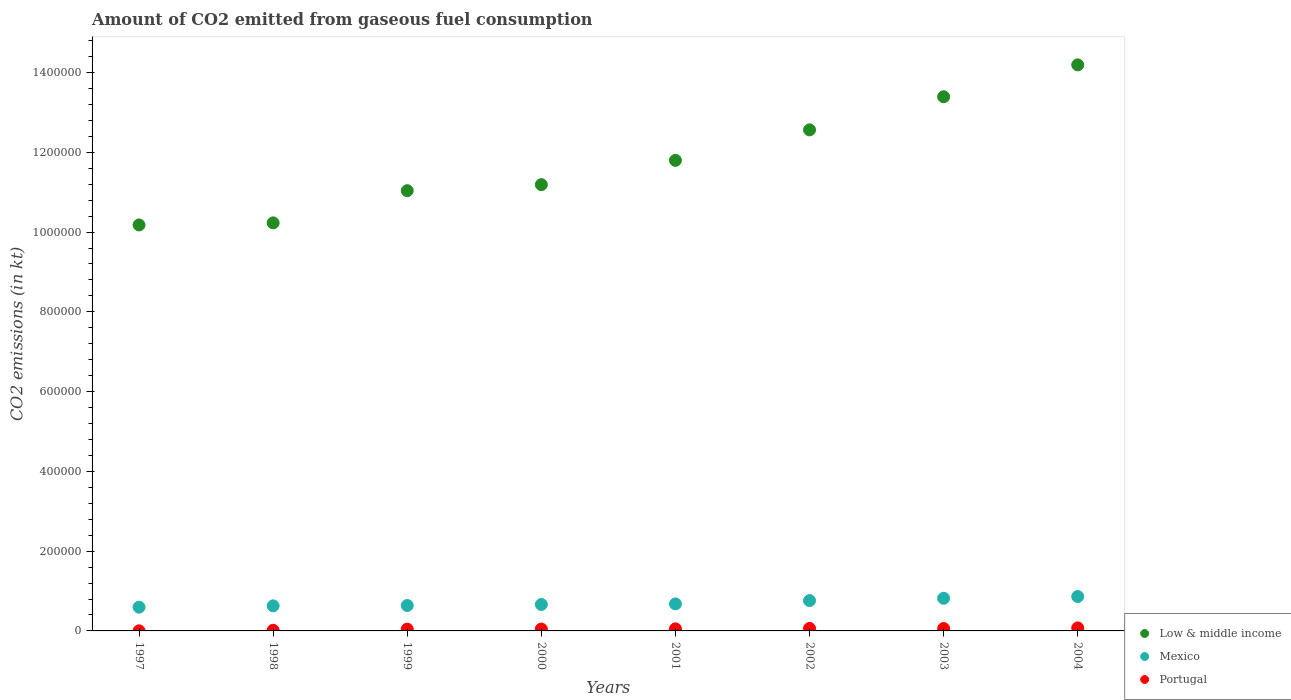How many different coloured dotlines are there?
Your answer should be compact. 3. What is the amount of CO2 emitted in Low & middle income in 2002?
Provide a succinct answer. 1.26e+06. Across all years, what is the maximum amount of CO2 emitted in Portugal?
Offer a terse response. 7565.02. Across all years, what is the minimum amount of CO2 emitted in Portugal?
Provide a short and direct response. 198.02. In which year was the amount of CO2 emitted in Low & middle income minimum?
Your answer should be compact. 1997. What is the total amount of CO2 emitted in Low & middle income in the graph?
Provide a short and direct response. 9.46e+06. What is the difference between the amount of CO2 emitted in Low & middle income in 2001 and that in 2004?
Your response must be concise. -2.39e+05. What is the difference between the amount of CO2 emitted in Low & middle income in 1998 and the amount of CO2 emitted in Portugal in 2003?
Give a very brief answer. 1.02e+06. What is the average amount of CO2 emitted in Portugal per year?
Provide a short and direct response. 4490.7. In the year 2003, what is the difference between the amount of CO2 emitted in Portugal and amount of CO2 emitted in Low & middle income?
Keep it short and to the point. -1.33e+06. In how many years, is the amount of CO2 emitted in Low & middle income greater than 1240000 kt?
Provide a short and direct response. 3. What is the ratio of the amount of CO2 emitted in Portugal in 1997 to that in 2000?
Provide a succinct answer. 0.04. Is the amount of CO2 emitted in Mexico in 2003 less than that in 2004?
Keep it short and to the point. Yes. What is the difference between the highest and the second highest amount of CO2 emitted in Low & middle income?
Ensure brevity in your answer.  7.99e+04. What is the difference between the highest and the lowest amount of CO2 emitted in Portugal?
Your answer should be compact. 7367. In how many years, is the amount of CO2 emitted in Low & middle income greater than the average amount of CO2 emitted in Low & middle income taken over all years?
Offer a very short reply. 3. Does the amount of CO2 emitted in Mexico monotonically increase over the years?
Give a very brief answer. Yes. How many dotlines are there?
Offer a terse response. 3. What is the difference between two consecutive major ticks on the Y-axis?
Make the answer very short. 2.00e+05. Are the values on the major ticks of Y-axis written in scientific E-notation?
Your response must be concise. No. Does the graph contain grids?
Provide a short and direct response. No. Where does the legend appear in the graph?
Make the answer very short. Bottom right. What is the title of the graph?
Your answer should be very brief. Amount of CO2 emitted from gaseous fuel consumption. Does "New Caledonia" appear as one of the legend labels in the graph?
Offer a terse response. No. What is the label or title of the Y-axis?
Keep it short and to the point. CO2 emissions (in kt). What is the CO2 emissions (in kt) of Low & middle income in 1997?
Provide a short and direct response. 1.02e+06. What is the CO2 emissions (in kt) in Mexico in 1997?
Keep it short and to the point. 5.96e+04. What is the CO2 emissions (in kt) in Portugal in 1997?
Your answer should be very brief. 198.02. What is the CO2 emissions (in kt) of Low & middle income in 1998?
Offer a very short reply. 1.02e+06. What is the CO2 emissions (in kt) of Mexico in 1998?
Offer a very short reply. 6.29e+04. What is the CO2 emissions (in kt) in Portugal in 1998?
Provide a short and direct response. 1595.14. What is the CO2 emissions (in kt) of Low & middle income in 1999?
Your answer should be compact. 1.10e+06. What is the CO2 emissions (in kt) in Mexico in 1999?
Give a very brief answer. 6.37e+04. What is the CO2 emissions (in kt) in Portugal in 1999?
Your response must be concise. 4455.4. What is the CO2 emissions (in kt) in Low & middle income in 2000?
Offer a terse response. 1.12e+06. What is the CO2 emissions (in kt) of Mexico in 2000?
Your answer should be very brief. 6.63e+04. What is the CO2 emissions (in kt) of Portugal in 2000?
Your answer should be very brief. 4657.09. What is the CO2 emissions (in kt) of Low & middle income in 2001?
Provide a short and direct response. 1.18e+06. What is the CO2 emissions (in kt) in Mexico in 2001?
Make the answer very short. 6.78e+04. What is the CO2 emissions (in kt) of Portugal in 2001?
Ensure brevity in your answer.  5163.14. What is the CO2 emissions (in kt) of Low & middle income in 2002?
Your response must be concise. 1.26e+06. What is the CO2 emissions (in kt) in Mexico in 2002?
Provide a succinct answer. 7.60e+04. What is the CO2 emissions (in kt) in Portugal in 2002?
Your answer should be very brief. 6252.23. What is the CO2 emissions (in kt) in Low & middle income in 2003?
Ensure brevity in your answer.  1.34e+06. What is the CO2 emissions (in kt) in Mexico in 2003?
Keep it short and to the point. 8.18e+04. What is the CO2 emissions (in kt) in Portugal in 2003?
Your response must be concise. 6039.55. What is the CO2 emissions (in kt) of Low & middle income in 2004?
Keep it short and to the point. 1.42e+06. What is the CO2 emissions (in kt) of Mexico in 2004?
Offer a terse response. 8.62e+04. What is the CO2 emissions (in kt) of Portugal in 2004?
Offer a terse response. 7565.02. Across all years, what is the maximum CO2 emissions (in kt) of Low & middle income?
Your response must be concise. 1.42e+06. Across all years, what is the maximum CO2 emissions (in kt) of Mexico?
Give a very brief answer. 8.62e+04. Across all years, what is the maximum CO2 emissions (in kt) of Portugal?
Keep it short and to the point. 7565.02. Across all years, what is the minimum CO2 emissions (in kt) of Low & middle income?
Your answer should be very brief. 1.02e+06. Across all years, what is the minimum CO2 emissions (in kt) of Mexico?
Your answer should be compact. 5.96e+04. Across all years, what is the minimum CO2 emissions (in kt) in Portugal?
Your answer should be very brief. 198.02. What is the total CO2 emissions (in kt) of Low & middle income in the graph?
Ensure brevity in your answer.  9.46e+06. What is the total CO2 emissions (in kt) of Mexico in the graph?
Provide a succinct answer. 5.64e+05. What is the total CO2 emissions (in kt) in Portugal in the graph?
Your answer should be compact. 3.59e+04. What is the difference between the CO2 emissions (in kt) in Low & middle income in 1997 and that in 1998?
Your answer should be compact. -5197.05. What is the difference between the CO2 emissions (in kt) of Mexico in 1997 and that in 1998?
Keep it short and to the point. -3300.3. What is the difference between the CO2 emissions (in kt) of Portugal in 1997 and that in 1998?
Give a very brief answer. -1397.13. What is the difference between the CO2 emissions (in kt) of Low & middle income in 1997 and that in 1999?
Give a very brief answer. -8.59e+04. What is the difference between the CO2 emissions (in kt) in Mexico in 1997 and that in 1999?
Make the answer very short. -4154.71. What is the difference between the CO2 emissions (in kt) in Portugal in 1997 and that in 1999?
Keep it short and to the point. -4257.39. What is the difference between the CO2 emissions (in kt) in Low & middle income in 1997 and that in 2000?
Make the answer very short. -1.01e+05. What is the difference between the CO2 emissions (in kt) of Mexico in 1997 and that in 2000?
Offer a terse response. -6703.28. What is the difference between the CO2 emissions (in kt) in Portugal in 1997 and that in 2000?
Your response must be concise. -4459.07. What is the difference between the CO2 emissions (in kt) of Low & middle income in 1997 and that in 2001?
Make the answer very short. -1.62e+05. What is the difference between the CO2 emissions (in kt) in Mexico in 1997 and that in 2001?
Offer a very short reply. -8228.75. What is the difference between the CO2 emissions (in kt) in Portugal in 1997 and that in 2001?
Provide a succinct answer. -4965.12. What is the difference between the CO2 emissions (in kt) in Low & middle income in 1997 and that in 2002?
Make the answer very short. -2.38e+05. What is the difference between the CO2 emissions (in kt) in Mexico in 1997 and that in 2002?
Offer a terse response. -1.65e+04. What is the difference between the CO2 emissions (in kt) of Portugal in 1997 and that in 2002?
Offer a very short reply. -6054.22. What is the difference between the CO2 emissions (in kt) in Low & middle income in 1997 and that in 2003?
Offer a terse response. -3.21e+05. What is the difference between the CO2 emissions (in kt) of Mexico in 1997 and that in 2003?
Keep it short and to the point. -2.23e+04. What is the difference between the CO2 emissions (in kt) in Portugal in 1997 and that in 2003?
Make the answer very short. -5841.53. What is the difference between the CO2 emissions (in kt) of Low & middle income in 1997 and that in 2004?
Offer a very short reply. -4.01e+05. What is the difference between the CO2 emissions (in kt) of Mexico in 1997 and that in 2004?
Your answer should be very brief. -2.67e+04. What is the difference between the CO2 emissions (in kt) of Portugal in 1997 and that in 2004?
Provide a succinct answer. -7367. What is the difference between the CO2 emissions (in kt) of Low & middle income in 1998 and that in 1999?
Your response must be concise. -8.07e+04. What is the difference between the CO2 emissions (in kt) of Mexico in 1998 and that in 1999?
Your answer should be compact. -854.41. What is the difference between the CO2 emissions (in kt) of Portugal in 1998 and that in 1999?
Provide a short and direct response. -2860.26. What is the difference between the CO2 emissions (in kt) in Low & middle income in 1998 and that in 2000?
Provide a short and direct response. -9.59e+04. What is the difference between the CO2 emissions (in kt) of Mexico in 1998 and that in 2000?
Your answer should be compact. -3402.98. What is the difference between the CO2 emissions (in kt) of Portugal in 1998 and that in 2000?
Give a very brief answer. -3061.95. What is the difference between the CO2 emissions (in kt) in Low & middle income in 1998 and that in 2001?
Keep it short and to the point. -1.57e+05. What is the difference between the CO2 emissions (in kt) in Mexico in 1998 and that in 2001?
Your answer should be compact. -4928.45. What is the difference between the CO2 emissions (in kt) of Portugal in 1998 and that in 2001?
Your response must be concise. -3567.99. What is the difference between the CO2 emissions (in kt) in Low & middle income in 1998 and that in 2002?
Your answer should be very brief. -2.33e+05. What is the difference between the CO2 emissions (in kt) in Mexico in 1998 and that in 2002?
Your response must be concise. -1.32e+04. What is the difference between the CO2 emissions (in kt) in Portugal in 1998 and that in 2002?
Make the answer very short. -4657.09. What is the difference between the CO2 emissions (in kt) in Low & middle income in 1998 and that in 2003?
Provide a succinct answer. -3.16e+05. What is the difference between the CO2 emissions (in kt) in Mexico in 1998 and that in 2003?
Make the answer very short. -1.90e+04. What is the difference between the CO2 emissions (in kt) in Portugal in 1998 and that in 2003?
Your answer should be compact. -4444.4. What is the difference between the CO2 emissions (in kt) in Low & middle income in 1998 and that in 2004?
Offer a very short reply. -3.96e+05. What is the difference between the CO2 emissions (in kt) of Mexico in 1998 and that in 2004?
Your response must be concise. -2.34e+04. What is the difference between the CO2 emissions (in kt) of Portugal in 1998 and that in 2004?
Offer a terse response. -5969.88. What is the difference between the CO2 emissions (in kt) in Low & middle income in 1999 and that in 2000?
Offer a very short reply. -1.52e+04. What is the difference between the CO2 emissions (in kt) in Mexico in 1999 and that in 2000?
Offer a very short reply. -2548.57. What is the difference between the CO2 emissions (in kt) in Portugal in 1999 and that in 2000?
Make the answer very short. -201.69. What is the difference between the CO2 emissions (in kt) of Low & middle income in 1999 and that in 2001?
Provide a short and direct response. -7.61e+04. What is the difference between the CO2 emissions (in kt) in Mexico in 1999 and that in 2001?
Offer a very short reply. -4074.04. What is the difference between the CO2 emissions (in kt) of Portugal in 1999 and that in 2001?
Offer a very short reply. -707.73. What is the difference between the CO2 emissions (in kt) in Low & middle income in 1999 and that in 2002?
Keep it short and to the point. -1.53e+05. What is the difference between the CO2 emissions (in kt) in Mexico in 1999 and that in 2002?
Your answer should be very brief. -1.23e+04. What is the difference between the CO2 emissions (in kt) in Portugal in 1999 and that in 2002?
Provide a succinct answer. -1796.83. What is the difference between the CO2 emissions (in kt) of Low & middle income in 1999 and that in 2003?
Provide a short and direct response. -2.36e+05. What is the difference between the CO2 emissions (in kt) in Mexico in 1999 and that in 2003?
Your answer should be compact. -1.81e+04. What is the difference between the CO2 emissions (in kt) of Portugal in 1999 and that in 2003?
Your answer should be compact. -1584.14. What is the difference between the CO2 emissions (in kt) in Low & middle income in 1999 and that in 2004?
Provide a succinct answer. -3.15e+05. What is the difference between the CO2 emissions (in kt) in Mexico in 1999 and that in 2004?
Offer a terse response. -2.25e+04. What is the difference between the CO2 emissions (in kt) in Portugal in 1999 and that in 2004?
Provide a succinct answer. -3109.62. What is the difference between the CO2 emissions (in kt) in Low & middle income in 2000 and that in 2001?
Your answer should be very brief. -6.09e+04. What is the difference between the CO2 emissions (in kt) in Mexico in 2000 and that in 2001?
Offer a terse response. -1525.47. What is the difference between the CO2 emissions (in kt) in Portugal in 2000 and that in 2001?
Keep it short and to the point. -506.05. What is the difference between the CO2 emissions (in kt) in Low & middle income in 2000 and that in 2002?
Your response must be concise. -1.37e+05. What is the difference between the CO2 emissions (in kt) in Mexico in 2000 and that in 2002?
Ensure brevity in your answer.  -9750.55. What is the difference between the CO2 emissions (in kt) of Portugal in 2000 and that in 2002?
Give a very brief answer. -1595.14. What is the difference between the CO2 emissions (in kt) in Low & middle income in 2000 and that in 2003?
Ensure brevity in your answer.  -2.20e+05. What is the difference between the CO2 emissions (in kt) in Mexico in 2000 and that in 2003?
Make the answer very short. -1.56e+04. What is the difference between the CO2 emissions (in kt) in Portugal in 2000 and that in 2003?
Give a very brief answer. -1382.46. What is the difference between the CO2 emissions (in kt) of Low & middle income in 2000 and that in 2004?
Give a very brief answer. -3.00e+05. What is the difference between the CO2 emissions (in kt) of Mexico in 2000 and that in 2004?
Offer a terse response. -2.00e+04. What is the difference between the CO2 emissions (in kt) in Portugal in 2000 and that in 2004?
Your answer should be compact. -2907.93. What is the difference between the CO2 emissions (in kt) of Low & middle income in 2001 and that in 2002?
Your response must be concise. -7.65e+04. What is the difference between the CO2 emissions (in kt) in Mexico in 2001 and that in 2002?
Provide a short and direct response. -8225.08. What is the difference between the CO2 emissions (in kt) of Portugal in 2001 and that in 2002?
Your answer should be compact. -1089.1. What is the difference between the CO2 emissions (in kt) of Low & middle income in 2001 and that in 2003?
Provide a succinct answer. -1.59e+05. What is the difference between the CO2 emissions (in kt) in Mexico in 2001 and that in 2003?
Keep it short and to the point. -1.41e+04. What is the difference between the CO2 emissions (in kt) of Portugal in 2001 and that in 2003?
Provide a short and direct response. -876.41. What is the difference between the CO2 emissions (in kt) of Low & middle income in 2001 and that in 2004?
Your response must be concise. -2.39e+05. What is the difference between the CO2 emissions (in kt) of Mexico in 2001 and that in 2004?
Your answer should be compact. -1.84e+04. What is the difference between the CO2 emissions (in kt) in Portugal in 2001 and that in 2004?
Keep it short and to the point. -2401.89. What is the difference between the CO2 emissions (in kt) in Low & middle income in 2002 and that in 2003?
Your answer should be compact. -8.30e+04. What is the difference between the CO2 emissions (in kt) in Mexico in 2002 and that in 2003?
Offer a very short reply. -5837.86. What is the difference between the CO2 emissions (in kt) in Portugal in 2002 and that in 2003?
Offer a terse response. 212.69. What is the difference between the CO2 emissions (in kt) in Low & middle income in 2002 and that in 2004?
Provide a short and direct response. -1.63e+05. What is the difference between the CO2 emissions (in kt) of Mexico in 2002 and that in 2004?
Your answer should be very brief. -1.02e+04. What is the difference between the CO2 emissions (in kt) in Portugal in 2002 and that in 2004?
Offer a very short reply. -1312.79. What is the difference between the CO2 emissions (in kt) of Low & middle income in 2003 and that in 2004?
Keep it short and to the point. -7.99e+04. What is the difference between the CO2 emissions (in kt) in Mexico in 2003 and that in 2004?
Provide a succinct answer. -4374.73. What is the difference between the CO2 emissions (in kt) of Portugal in 2003 and that in 2004?
Keep it short and to the point. -1525.47. What is the difference between the CO2 emissions (in kt) in Low & middle income in 1997 and the CO2 emissions (in kt) in Mexico in 1998?
Your answer should be compact. 9.55e+05. What is the difference between the CO2 emissions (in kt) of Low & middle income in 1997 and the CO2 emissions (in kt) of Portugal in 1998?
Offer a terse response. 1.02e+06. What is the difference between the CO2 emissions (in kt) of Mexico in 1997 and the CO2 emissions (in kt) of Portugal in 1998?
Offer a very short reply. 5.80e+04. What is the difference between the CO2 emissions (in kt) of Low & middle income in 1997 and the CO2 emissions (in kt) of Mexico in 1999?
Make the answer very short. 9.54e+05. What is the difference between the CO2 emissions (in kt) in Low & middle income in 1997 and the CO2 emissions (in kt) in Portugal in 1999?
Keep it short and to the point. 1.01e+06. What is the difference between the CO2 emissions (in kt) of Mexico in 1997 and the CO2 emissions (in kt) of Portugal in 1999?
Your answer should be compact. 5.51e+04. What is the difference between the CO2 emissions (in kt) of Low & middle income in 1997 and the CO2 emissions (in kt) of Mexico in 2000?
Ensure brevity in your answer.  9.52e+05. What is the difference between the CO2 emissions (in kt) of Low & middle income in 1997 and the CO2 emissions (in kt) of Portugal in 2000?
Provide a succinct answer. 1.01e+06. What is the difference between the CO2 emissions (in kt) in Mexico in 1997 and the CO2 emissions (in kt) in Portugal in 2000?
Ensure brevity in your answer.  5.49e+04. What is the difference between the CO2 emissions (in kt) in Low & middle income in 1997 and the CO2 emissions (in kt) in Mexico in 2001?
Keep it short and to the point. 9.50e+05. What is the difference between the CO2 emissions (in kt) in Low & middle income in 1997 and the CO2 emissions (in kt) in Portugal in 2001?
Offer a terse response. 1.01e+06. What is the difference between the CO2 emissions (in kt) of Mexico in 1997 and the CO2 emissions (in kt) of Portugal in 2001?
Offer a terse response. 5.44e+04. What is the difference between the CO2 emissions (in kt) of Low & middle income in 1997 and the CO2 emissions (in kt) of Mexico in 2002?
Give a very brief answer. 9.42e+05. What is the difference between the CO2 emissions (in kt) in Low & middle income in 1997 and the CO2 emissions (in kt) in Portugal in 2002?
Offer a terse response. 1.01e+06. What is the difference between the CO2 emissions (in kt) in Mexico in 1997 and the CO2 emissions (in kt) in Portugal in 2002?
Ensure brevity in your answer.  5.33e+04. What is the difference between the CO2 emissions (in kt) in Low & middle income in 1997 and the CO2 emissions (in kt) in Mexico in 2003?
Keep it short and to the point. 9.36e+05. What is the difference between the CO2 emissions (in kt) in Low & middle income in 1997 and the CO2 emissions (in kt) in Portugal in 2003?
Offer a terse response. 1.01e+06. What is the difference between the CO2 emissions (in kt) of Mexico in 1997 and the CO2 emissions (in kt) of Portugal in 2003?
Your response must be concise. 5.35e+04. What is the difference between the CO2 emissions (in kt) of Low & middle income in 1997 and the CO2 emissions (in kt) of Mexico in 2004?
Offer a terse response. 9.32e+05. What is the difference between the CO2 emissions (in kt) in Low & middle income in 1997 and the CO2 emissions (in kt) in Portugal in 2004?
Make the answer very short. 1.01e+06. What is the difference between the CO2 emissions (in kt) of Mexico in 1997 and the CO2 emissions (in kt) of Portugal in 2004?
Make the answer very short. 5.20e+04. What is the difference between the CO2 emissions (in kt) in Low & middle income in 1998 and the CO2 emissions (in kt) in Mexico in 1999?
Your answer should be compact. 9.59e+05. What is the difference between the CO2 emissions (in kt) in Low & middle income in 1998 and the CO2 emissions (in kt) in Portugal in 1999?
Offer a terse response. 1.02e+06. What is the difference between the CO2 emissions (in kt) of Mexico in 1998 and the CO2 emissions (in kt) of Portugal in 1999?
Your answer should be compact. 5.84e+04. What is the difference between the CO2 emissions (in kt) in Low & middle income in 1998 and the CO2 emissions (in kt) in Mexico in 2000?
Provide a short and direct response. 9.57e+05. What is the difference between the CO2 emissions (in kt) of Low & middle income in 1998 and the CO2 emissions (in kt) of Portugal in 2000?
Your answer should be compact. 1.02e+06. What is the difference between the CO2 emissions (in kt) in Mexico in 1998 and the CO2 emissions (in kt) in Portugal in 2000?
Give a very brief answer. 5.82e+04. What is the difference between the CO2 emissions (in kt) in Low & middle income in 1998 and the CO2 emissions (in kt) in Mexico in 2001?
Make the answer very short. 9.55e+05. What is the difference between the CO2 emissions (in kt) of Low & middle income in 1998 and the CO2 emissions (in kt) of Portugal in 2001?
Offer a very short reply. 1.02e+06. What is the difference between the CO2 emissions (in kt) of Mexico in 1998 and the CO2 emissions (in kt) of Portugal in 2001?
Ensure brevity in your answer.  5.77e+04. What is the difference between the CO2 emissions (in kt) of Low & middle income in 1998 and the CO2 emissions (in kt) of Mexico in 2002?
Your response must be concise. 9.47e+05. What is the difference between the CO2 emissions (in kt) of Low & middle income in 1998 and the CO2 emissions (in kt) of Portugal in 2002?
Provide a succinct answer. 1.02e+06. What is the difference between the CO2 emissions (in kt) in Mexico in 1998 and the CO2 emissions (in kt) in Portugal in 2002?
Provide a succinct answer. 5.66e+04. What is the difference between the CO2 emissions (in kt) of Low & middle income in 1998 and the CO2 emissions (in kt) of Mexico in 2003?
Offer a very short reply. 9.41e+05. What is the difference between the CO2 emissions (in kt) in Low & middle income in 1998 and the CO2 emissions (in kt) in Portugal in 2003?
Ensure brevity in your answer.  1.02e+06. What is the difference between the CO2 emissions (in kt) of Mexico in 1998 and the CO2 emissions (in kt) of Portugal in 2003?
Ensure brevity in your answer.  5.68e+04. What is the difference between the CO2 emissions (in kt) of Low & middle income in 1998 and the CO2 emissions (in kt) of Mexico in 2004?
Your answer should be compact. 9.37e+05. What is the difference between the CO2 emissions (in kt) of Low & middle income in 1998 and the CO2 emissions (in kt) of Portugal in 2004?
Offer a terse response. 1.02e+06. What is the difference between the CO2 emissions (in kt) in Mexico in 1998 and the CO2 emissions (in kt) in Portugal in 2004?
Ensure brevity in your answer.  5.53e+04. What is the difference between the CO2 emissions (in kt) in Low & middle income in 1999 and the CO2 emissions (in kt) in Mexico in 2000?
Your response must be concise. 1.04e+06. What is the difference between the CO2 emissions (in kt) of Low & middle income in 1999 and the CO2 emissions (in kt) of Portugal in 2000?
Give a very brief answer. 1.10e+06. What is the difference between the CO2 emissions (in kt) in Mexico in 1999 and the CO2 emissions (in kt) in Portugal in 2000?
Offer a terse response. 5.91e+04. What is the difference between the CO2 emissions (in kt) in Low & middle income in 1999 and the CO2 emissions (in kt) in Mexico in 2001?
Make the answer very short. 1.04e+06. What is the difference between the CO2 emissions (in kt) of Low & middle income in 1999 and the CO2 emissions (in kt) of Portugal in 2001?
Give a very brief answer. 1.10e+06. What is the difference between the CO2 emissions (in kt) of Mexico in 1999 and the CO2 emissions (in kt) of Portugal in 2001?
Your response must be concise. 5.85e+04. What is the difference between the CO2 emissions (in kt) in Low & middle income in 1999 and the CO2 emissions (in kt) in Mexico in 2002?
Ensure brevity in your answer.  1.03e+06. What is the difference between the CO2 emissions (in kt) in Low & middle income in 1999 and the CO2 emissions (in kt) in Portugal in 2002?
Your response must be concise. 1.10e+06. What is the difference between the CO2 emissions (in kt) of Mexico in 1999 and the CO2 emissions (in kt) of Portugal in 2002?
Offer a terse response. 5.75e+04. What is the difference between the CO2 emissions (in kt) of Low & middle income in 1999 and the CO2 emissions (in kt) of Mexico in 2003?
Provide a short and direct response. 1.02e+06. What is the difference between the CO2 emissions (in kt) of Low & middle income in 1999 and the CO2 emissions (in kt) of Portugal in 2003?
Ensure brevity in your answer.  1.10e+06. What is the difference between the CO2 emissions (in kt) of Mexico in 1999 and the CO2 emissions (in kt) of Portugal in 2003?
Offer a terse response. 5.77e+04. What is the difference between the CO2 emissions (in kt) of Low & middle income in 1999 and the CO2 emissions (in kt) of Mexico in 2004?
Offer a very short reply. 1.02e+06. What is the difference between the CO2 emissions (in kt) in Low & middle income in 1999 and the CO2 emissions (in kt) in Portugal in 2004?
Keep it short and to the point. 1.10e+06. What is the difference between the CO2 emissions (in kt) of Mexico in 1999 and the CO2 emissions (in kt) of Portugal in 2004?
Your answer should be compact. 5.61e+04. What is the difference between the CO2 emissions (in kt) of Low & middle income in 2000 and the CO2 emissions (in kt) of Mexico in 2001?
Provide a short and direct response. 1.05e+06. What is the difference between the CO2 emissions (in kt) of Low & middle income in 2000 and the CO2 emissions (in kt) of Portugal in 2001?
Provide a short and direct response. 1.11e+06. What is the difference between the CO2 emissions (in kt) in Mexico in 2000 and the CO2 emissions (in kt) in Portugal in 2001?
Offer a very short reply. 6.11e+04. What is the difference between the CO2 emissions (in kt) in Low & middle income in 2000 and the CO2 emissions (in kt) in Mexico in 2002?
Offer a very short reply. 1.04e+06. What is the difference between the CO2 emissions (in kt) of Low & middle income in 2000 and the CO2 emissions (in kt) of Portugal in 2002?
Offer a terse response. 1.11e+06. What is the difference between the CO2 emissions (in kt) in Mexico in 2000 and the CO2 emissions (in kt) in Portugal in 2002?
Ensure brevity in your answer.  6.00e+04. What is the difference between the CO2 emissions (in kt) in Low & middle income in 2000 and the CO2 emissions (in kt) in Mexico in 2003?
Your answer should be compact. 1.04e+06. What is the difference between the CO2 emissions (in kt) of Low & middle income in 2000 and the CO2 emissions (in kt) of Portugal in 2003?
Your response must be concise. 1.11e+06. What is the difference between the CO2 emissions (in kt) in Mexico in 2000 and the CO2 emissions (in kt) in Portugal in 2003?
Give a very brief answer. 6.02e+04. What is the difference between the CO2 emissions (in kt) in Low & middle income in 2000 and the CO2 emissions (in kt) in Mexico in 2004?
Keep it short and to the point. 1.03e+06. What is the difference between the CO2 emissions (in kt) in Low & middle income in 2000 and the CO2 emissions (in kt) in Portugal in 2004?
Your answer should be compact. 1.11e+06. What is the difference between the CO2 emissions (in kt) of Mexico in 2000 and the CO2 emissions (in kt) of Portugal in 2004?
Your answer should be compact. 5.87e+04. What is the difference between the CO2 emissions (in kt) of Low & middle income in 2001 and the CO2 emissions (in kt) of Mexico in 2002?
Make the answer very short. 1.10e+06. What is the difference between the CO2 emissions (in kt) of Low & middle income in 2001 and the CO2 emissions (in kt) of Portugal in 2002?
Offer a very short reply. 1.17e+06. What is the difference between the CO2 emissions (in kt) in Mexico in 2001 and the CO2 emissions (in kt) in Portugal in 2002?
Ensure brevity in your answer.  6.15e+04. What is the difference between the CO2 emissions (in kt) of Low & middle income in 2001 and the CO2 emissions (in kt) of Mexico in 2003?
Offer a very short reply. 1.10e+06. What is the difference between the CO2 emissions (in kt) of Low & middle income in 2001 and the CO2 emissions (in kt) of Portugal in 2003?
Keep it short and to the point. 1.17e+06. What is the difference between the CO2 emissions (in kt) in Mexico in 2001 and the CO2 emissions (in kt) in Portugal in 2003?
Your answer should be compact. 6.17e+04. What is the difference between the CO2 emissions (in kt) of Low & middle income in 2001 and the CO2 emissions (in kt) of Mexico in 2004?
Offer a very short reply. 1.09e+06. What is the difference between the CO2 emissions (in kt) of Low & middle income in 2001 and the CO2 emissions (in kt) of Portugal in 2004?
Offer a terse response. 1.17e+06. What is the difference between the CO2 emissions (in kt) in Mexico in 2001 and the CO2 emissions (in kt) in Portugal in 2004?
Keep it short and to the point. 6.02e+04. What is the difference between the CO2 emissions (in kt) of Low & middle income in 2002 and the CO2 emissions (in kt) of Mexico in 2003?
Your answer should be very brief. 1.17e+06. What is the difference between the CO2 emissions (in kt) of Low & middle income in 2002 and the CO2 emissions (in kt) of Portugal in 2003?
Provide a succinct answer. 1.25e+06. What is the difference between the CO2 emissions (in kt) in Mexico in 2002 and the CO2 emissions (in kt) in Portugal in 2003?
Make the answer very short. 7.00e+04. What is the difference between the CO2 emissions (in kt) of Low & middle income in 2002 and the CO2 emissions (in kt) of Mexico in 2004?
Your answer should be very brief. 1.17e+06. What is the difference between the CO2 emissions (in kt) of Low & middle income in 2002 and the CO2 emissions (in kt) of Portugal in 2004?
Give a very brief answer. 1.25e+06. What is the difference between the CO2 emissions (in kt) of Mexico in 2002 and the CO2 emissions (in kt) of Portugal in 2004?
Offer a terse response. 6.84e+04. What is the difference between the CO2 emissions (in kt) in Low & middle income in 2003 and the CO2 emissions (in kt) in Mexico in 2004?
Offer a very short reply. 1.25e+06. What is the difference between the CO2 emissions (in kt) in Low & middle income in 2003 and the CO2 emissions (in kt) in Portugal in 2004?
Your answer should be compact. 1.33e+06. What is the difference between the CO2 emissions (in kt) of Mexico in 2003 and the CO2 emissions (in kt) of Portugal in 2004?
Ensure brevity in your answer.  7.43e+04. What is the average CO2 emissions (in kt) of Low & middle income per year?
Your answer should be compact. 1.18e+06. What is the average CO2 emissions (in kt) in Mexico per year?
Keep it short and to the point. 7.05e+04. What is the average CO2 emissions (in kt) in Portugal per year?
Your answer should be compact. 4490.7. In the year 1997, what is the difference between the CO2 emissions (in kt) in Low & middle income and CO2 emissions (in kt) in Mexico?
Offer a terse response. 9.58e+05. In the year 1997, what is the difference between the CO2 emissions (in kt) in Low & middle income and CO2 emissions (in kt) in Portugal?
Offer a terse response. 1.02e+06. In the year 1997, what is the difference between the CO2 emissions (in kt) of Mexico and CO2 emissions (in kt) of Portugal?
Your answer should be compact. 5.94e+04. In the year 1998, what is the difference between the CO2 emissions (in kt) of Low & middle income and CO2 emissions (in kt) of Mexico?
Give a very brief answer. 9.60e+05. In the year 1998, what is the difference between the CO2 emissions (in kt) of Low & middle income and CO2 emissions (in kt) of Portugal?
Keep it short and to the point. 1.02e+06. In the year 1998, what is the difference between the CO2 emissions (in kt) in Mexico and CO2 emissions (in kt) in Portugal?
Provide a short and direct response. 6.13e+04. In the year 1999, what is the difference between the CO2 emissions (in kt) of Low & middle income and CO2 emissions (in kt) of Mexico?
Offer a terse response. 1.04e+06. In the year 1999, what is the difference between the CO2 emissions (in kt) of Low & middle income and CO2 emissions (in kt) of Portugal?
Offer a terse response. 1.10e+06. In the year 1999, what is the difference between the CO2 emissions (in kt) of Mexico and CO2 emissions (in kt) of Portugal?
Keep it short and to the point. 5.93e+04. In the year 2000, what is the difference between the CO2 emissions (in kt) in Low & middle income and CO2 emissions (in kt) in Mexico?
Offer a very short reply. 1.05e+06. In the year 2000, what is the difference between the CO2 emissions (in kt) in Low & middle income and CO2 emissions (in kt) in Portugal?
Your answer should be compact. 1.11e+06. In the year 2000, what is the difference between the CO2 emissions (in kt) of Mexico and CO2 emissions (in kt) of Portugal?
Your response must be concise. 6.16e+04. In the year 2001, what is the difference between the CO2 emissions (in kt) of Low & middle income and CO2 emissions (in kt) of Mexico?
Ensure brevity in your answer.  1.11e+06. In the year 2001, what is the difference between the CO2 emissions (in kt) of Low & middle income and CO2 emissions (in kt) of Portugal?
Make the answer very short. 1.17e+06. In the year 2001, what is the difference between the CO2 emissions (in kt) in Mexico and CO2 emissions (in kt) in Portugal?
Offer a terse response. 6.26e+04. In the year 2002, what is the difference between the CO2 emissions (in kt) of Low & middle income and CO2 emissions (in kt) of Mexico?
Provide a short and direct response. 1.18e+06. In the year 2002, what is the difference between the CO2 emissions (in kt) of Low & middle income and CO2 emissions (in kt) of Portugal?
Your answer should be very brief. 1.25e+06. In the year 2002, what is the difference between the CO2 emissions (in kt) in Mexico and CO2 emissions (in kt) in Portugal?
Offer a terse response. 6.98e+04. In the year 2003, what is the difference between the CO2 emissions (in kt) in Low & middle income and CO2 emissions (in kt) in Mexico?
Your response must be concise. 1.26e+06. In the year 2003, what is the difference between the CO2 emissions (in kt) of Low & middle income and CO2 emissions (in kt) of Portugal?
Provide a succinct answer. 1.33e+06. In the year 2003, what is the difference between the CO2 emissions (in kt) in Mexico and CO2 emissions (in kt) in Portugal?
Your response must be concise. 7.58e+04. In the year 2004, what is the difference between the CO2 emissions (in kt) of Low & middle income and CO2 emissions (in kt) of Mexico?
Provide a short and direct response. 1.33e+06. In the year 2004, what is the difference between the CO2 emissions (in kt) in Low & middle income and CO2 emissions (in kt) in Portugal?
Your answer should be very brief. 1.41e+06. In the year 2004, what is the difference between the CO2 emissions (in kt) in Mexico and CO2 emissions (in kt) in Portugal?
Make the answer very short. 7.87e+04. What is the ratio of the CO2 emissions (in kt) in Mexico in 1997 to that in 1998?
Your answer should be very brief. 0.95. What is the ratio of the CO2 emissions (in kt) of Portugal in 1997 to that in 1998?
Make the answer very short. 0.12. What is the ratio of the CO2 emissions (in kt) of Low & middle income in 1997 to that in 1999?
Keep it short and to the point. 0.92. What is the ratio of the CO2 emissions (in kt) in Mexico in 1997 to that in 1999?
Provide a short and direct response. 0.93. What is the ratio of the CO2 emissions (in kt) of Portugal in 1997 to that in 1999?
Give a very brief answer. 0.04. What is the ratio of the CO2 emissions (in kt) in Low & middle income in 1997 to that in 2000?
Provide a succinct answer. 0.91. What is the ratio of the CO2 emissions (in kt) of Mexico in 1997 to that in 2000?
Make the answer very short. 0.9. What is the ratio of the CO2 emissions (in kt) of Portugal in 1997 to that in 2000?
Ensure brevity in your answer.  0.04. What is the ratio of the CO2 emissions (in kt) of Low & middle income in 1997 to that in 2001?
Ensure brevity in your answer.  0.86. What is the ratio of the CO2 emissions (in kt) in Mexico in 1997 to that in 2001?
Keep it short and to the point. 0.88. What is the ratio of the CO2 emissions (in kt) of Portugal in 1997 to that in 2001?
Keep it short and to the point. 0.04. What is the ratio of the CO2 emissions (in kt) of Low & middle income in 1997 to that in 2002?
Provide a short and direct response. 0.81. What is the ratio of the CO2 emissions (in kt) of Mexico in 1997 to that in 2002?
Offer a very short reply. 0.78. What is the ratio of the CO2 emissions (in kt) in Portugal in 1997 to that in 2002?
Give a very brief answer. 0.03. What is the ratio of the CO2 emissions (in kt) in Low & middle income in 1997 to that in 2003?
Provide a succinct answer. 0.76. What is the ratio of the CO2 emissions (in kt) in Mexico in 1997 to that in 2003?
Your answer should be very brief. 0.73. What is the ratio of the CO2 emissions (in kt) of Portugal in 1997 to that in 2003?
Your answer should be very brief. 0.03. What is the ratio of the CO2 emissions (in kt) in Low & middle income in 1997 to that in 2004?
Your answer should be very brief. 0.72. What is the ratio of the CO2 emissions (in kt) of Mexico in 1997 to that in 2004?
Ensure brevity in your answer.  0.69. What is the ratio of the CO2 emissions (in kt) of Portugal in 1997 to that in 2004?
Keep it short and to the point. 0.03. What is the ratio of the CO2 emissions (in kt) in Low & middle income in 1998 to that in 1999?
Offer a very short reply. 0.93. What is the ratio of the CO2 emissions (in kt) in Mexico in 1998 to that in 1999?
Provide a short and direct response. 0.99. What is the ratio of the CO2 emissions (in kt) of Portugal in 1998 to that in 1999?
Make the answer very short. 0.36. What is the ratio of the CO2 emissions (in kt) of Low & middle income in 1998 to that in 2000?
Provide a succinct answer. 0.91. What is the ratio of the CO2 emissions (in kt) of Mexico in 1998 to that in 2000?
Keep it short and to the point. 0.95. What is the ratio of the CO2 emissions (in kt) in Portugal in 1998 to that in 2000?
Your response must be concise. 0.34. What is the ratio of the CO2 emissions (in kt) of Low & middle income in 1998 to that in 2001?
Ensure brevity in your answer.  0.87. What is the ratio of the CO2 emissions (in kt) in Mexico in 1998 to that in 2001?
Provide a short and direct response. 0.93. What is the ratio of the CO2 emissions (in kt) of Portugal in 1998 to that in 2001?
Your answer should be compact. 0.31. What is the ratio of the CO2 emissions (in kt) in Low & middle income in 1998 to that in 2002?
Provide a short and direct response. 0.81. What is the ratio of the CO2 emissions (in kt) in Mexico in 1998 to that in 2002?
Your answer should be compact. 0.83. What is the ratio of the CO2 emissions (in kt) in Portugal in 1998 to that in 2002?
Make the answer very short. 0.26. What is the ratio of the CO2 emissions (in kt) of Low & middle income in 1998 to that in 2003?
Provide a succinct answer. 0.76. What is the ratio of the CO2 emissions (in kt) of Mexico in 1998 to that in 2003?
Provide a succinct answer. 0.77. What is the ratio of the CO2 emissions (in kt) of Portugal in 1998 to that in 2003?
Make the answer very short. 0.26. What is the ratio of the CO2 emissions (in kt) in Low & middle income in 1998 to that in 2004?
Your answer should be compact. 0.72. What is the ratio of the CO2 emissions (in kt) in Mexico in 1998 to that in 2004?
Keep it short and to the point. 0.73. What is the ratio of the CO2 emissions (in kt) of Portugal in 1998 to that in 2004?
Provide a short and direct response. 0.21. What is the ratio of the CO2 emissions (in kt) in Low & middle income in 1999 to that in 2000?
Provide a short and direct response. 0.99. What is the ratio of the CO2 emissions (in kt) of Mexico in 1999 to that in 2000?
Ensure brevity in your answer.  0.96. What is the ratio of the CO2 emissions (in kt) in Portugal in 1999 to that in 2000?
Give a very brief answer. 0.96. What is the ratio of the CO2 emissions (in kt) in Low & middle income in 1999 to that in 2001?
Provide a succinct answer. 0.94. What is the ratio of the CO2 emissions (in kt) in Mexico in 1999 to that in 2001?
Your answer should be very brief. 0.94. What is the ratio of the CO2 emissions (in kt) in Portugal in 1999 to that in 2001?
Provide a succinct answer. 0.86. What is the ratio of the CO2 emissions (in kt) of Low & middle income in 1999 to that in 2002?
Your response must be concise. 0.88. What is the ratio of the CO2 emissions (in kt) in Mexico in 1999 to that in 2002?
Your answer should be very brief. 0.84. What is the ratio of the CO2 emissions (in kt) of Portugal in 1999 to that in 2002?
Give a very brief answer. 0.71. What is the ratio of the CO2 emissions (in kt) of Low & middle income in 1999 to that in 2003?
Offer a terse response. 0.82. What is the ratio of the CO2 emissions (in kt) in Mexico in 1999 to that in 2003?
Ensure brevity in your answer.  0.78. What is the ratio of the CO2 emissions (in kt) of Portugal in 1999 to that in 2003?
Your answer should be compact. 0.74. What is the ratio of the CO2 emissions (in kt) of Low & middle income in 1999 to that in 2004?
Your response must be concise. 0.78. What is the ratio of the CO2 emissions (in kt) of Mexico in 1999 to that in 2004?
Keep it short and to the point. 0.74. What is the ratio of the CO2 emissions (in kt) of Portugal in 1999 to that in 2004?
Give a very brief answer. 0.59. What is the ratio of the CO2 emissions (in kt) in Low & middle income in 2000 to that in 2001?
Give a very brief answer. 0.95. What is the ratio of the CO2 emissions (in kt) in Mexico in 2000 to that in 2001?
Provide a succinct answer. 0.98. What is the ratio of the CO2 emissions (in kt) in Portugal in 2000 to that in 2001?
Your answer should be compact. 0.9. What is the ratio of the CO2 emissions (in kt) of Low & middle income in 2000 to that in 2002?
Offer a terse response. 0.89. What is the ratio of the CO2 emissions (in kt) in Mexico in 2000 to that in 2002?
Offer a very short reply. 0.87. What is the ratio of the CO2 emissions (in kt) in Portugal in 2000 to that in 2002?
Offer a very short reply. 0.74. What is the ratio of the CO2 emissions (in kt) in Low & middle income in 2000 to that in 2003?
Provide a short and direct response. 0.84. What is the ratio of the CO2 emissions (in kt) of Mexico in 2000 to that in 2003?
Offer a very short reply. 0.81. What is the ratio of the CO2 emissions (in kt) of Portugal in 2000 to that in 2003?
Give a very brief answer. 0.77. What is the ratio of the CO2 emissions (in kt) of Low & middle income in 2000 to that in 2004?
Keep it short and to the point. 0.79. What is the ratio of the CO2 emissions (in kt) of Mexico in 2000 to that in 2004?
Offer a terse response. 0.77. What is the ratio of the CO2 emissions (in kt) of Portugal in 2000 to that in 2004?
Offer a terse response. 0.62. What is the ratio of the CO2 emissions (in kt) in Low & middle income in 2001 to that in 2002?
Your answer should be very brief. 0.94. What is the ratio of the CO2 emissions (in kt) of Mexico in 2001 to that in 2002?
Your answer should be compact. 0.89. What is the ratio of the CO2 emissions (in kt) of Portugal in 2001 to that in 2002?
Give a very brief answer. 0.83. What is the ratio of the CO2 emissions (in kt) of Low & middle income in 2001 to that in 2003?
Offer a very short reply. 0.88. What is the ratio of the CO2 emissions (in kt) of Mexico in 2001 to that in 2003?
Your response must be concise. 0.83. What is the ratio of the CO2 emissions (in kt) in Portugal in 2001 to that in 2003?
Give a very brief answer. 0.85. What is the ratio of the CO2 emissions (in kt) of Low & middle income in 2001 to that in 2004?
Provide a short and direct response. 0.83. What is the ratio of the CO2 emissions (in kt) of Mexico in 2001 to that in 2004?
Your answer should be compact. 0.79. What is the ratio of the CO2 emissions (in kt) in Portugal in 2001 to that in 2004?
Keep it short and to the point. 0.68. What is the ratio of the CO2 emissions (in kt) in Low & middle income in 2002 to that in 2003?
Your answer should be very brief. 0.94. What is the ratio of the CO2 emissions (in kt) of Mexico in 2002 to that in 2003?
Ensure brevity in your answer.  0.93. What is the ratio of the CO2 emissions (in kt) of Portugal in 2002 to that in 2003?
Make the answer very short. 1.04. What is the ratio of the CO2 emissions (in kt) in Low & middle income in 2002 to that in 2004?
Keep it short and to the point. 0.89. What is the ratio of the CO2 emissions (in kt) in Mexico in 2002 to that in 2004?
Offer a very short reply. 0.88. What is the ratio of the CO2 emissions (in kt) in Portugal in 2002 to that in 2004?
Your answer should be very brief. 0.83. What is the ratio of the CO2 emissions (in kt) of Low & middle income in 2003 to that in 2004?
Offer a terse response. 0.94. What is the ratio of the CO2 emissions (in kt) in Mexico in 2003 to that in 2004?
Your answer should be very brief. 0.95. What is the ratio of the CO2 emissions (in kt) in Portugal in 2003 to that in 2004?
Offer a very short reply. 0.8. What is the difference between the highest and the second highest CO2 emissions (in kt) of Low & middle income?
Give a very brief answer. 7.99e+04. What is the difference between the highest and the second highest CO2 emissions (in kt) of Mexico?
Your answer should be very brief. 4374.73. What is the difference between the highest and the second highest CO2 emissions (in kt) of Portugal?
Provide a succinct answer. 1312.79. What is the difference between the highest and the lowest CO2 emissions (in kt) in Low & middle income?
Make the answer very short. 4.01e+05. What is the difference between the highest and the lowest CO2 emissions (in kt) in Mexico?
Your response must be concise. 2.67e+04. What is the difference between the highest and the lowest CO2 emissions (in kt) of Portugal?
Keep it short and to the point. 7367. 